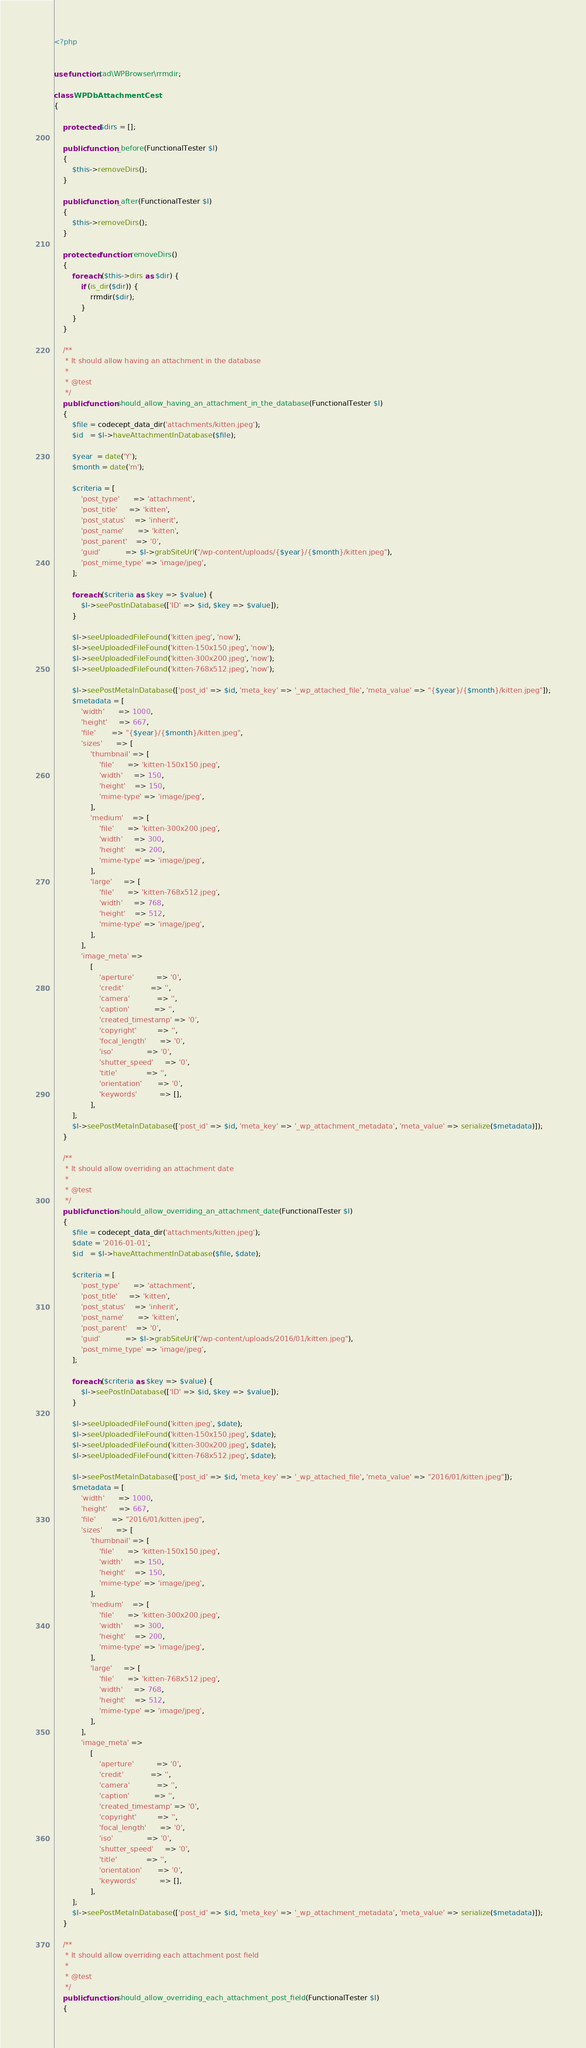Convert code to text. <code><loc_0><loc_0><loc_500><loc_500><_PHP_><?php


use function tad\WPBrowser\rrmdir;

class WPDbAttachmentCest
{

    protected $dirs = [];

    public function _before(FunctionalTester $I)
    {
        $this->removeDirs();
    }

    public function _after(FunctionalTester $I)
    {
        $this->removeDirs();
    }

    protected function removeDirs()
    {
        foreach ($this->dirs as $dir) {
            if (is_dir($dir)) {
                rrmdir($dir);
            }
        }
    }

    /**
     * It should allow having an attachment in the database
     *
     * @test
     */
    public function should_allow_having_an_attachment_in_the_database(FunctionalTester $I)
    {
        $file = codecept_data_dir('attachments/kitten.jpeg');
        $id   = $I->haveAttachmentInDatabase($file);

        $year  = date('Y');
        $month = date('m');

        $criteria = [
            'post_type'      => 'attachment',
            'post_title'     => 'kitten',
            'post_status'    => 'inherit',
            'post_name'      => 'kitten',
            'post_parent'    => '0',
            'guid'           => $I->grabSiteUrl("/wp-content/uploads/{$year}/{$month}/kitten.jpeg"),
            'post_mime_type' => 'image/jpeg',
        ];

        foreach ($criteria as $key => $value) {
            $I->seePostInDatabase(['ID' => $id, $key => $value]);
        }

        $I->seeUploadedFileFound('kitten.jpeg', 'now');
        $I->seeUploadedFileFound('kitten-150x150.jpeg', 'now');
        $I->seeUploadedFileFound('kitten-300x200.jpeg', 'now');
        $I->seeUploadedFileFound('kitten-768x512.jpeg', 'now');

        $I->seePostMetaInDatabase(['post_id' => $id, 'meta_key' => '_wp_attached_file', 'meta_value' => "{$year}/{$month}/kitten.jpeg"]);
        $metadata = [
            'width'      => 1000,
            'height'     => 667,
            'file'       => "{$year}/{$month}/kitten.jpeg",
            'sizes'      => [
                'thumbnail' => [
                    'file'      => 'kitten-150x150.jpeg',
                    'width'     => 150,
                    'height'    => 150,
                    'mime-type' => 'image/jpeg',
                ],
                'medium'    => [
                    'file'      => 'kitten-300x200.jpeg',
                    'width'     => 300,
                    'height'    => 200,
                    'mime-type' => 'image/jpeg',
                ],
                'large'     => [
                    'file'      => 'kitten-768x512.jpeg',
                    'width'     => 768,
                    'height'    => 512,
                    'mime-type' => 'image/jpeg',
                ],
            ],
            'image_meta' =>
                [
                    'aperture'          => '0',
                    'credit'            => '',
                    'camera'            => '',
                    'caption'           => '',
                    'created_timestamp' => '0',
                    'copyright'         => '',
                    'focal_length'      => '0',
                    'iso'               => '0',
                    'shutter_speed'     => '0',
                    'title'             => '',
                    'orientation'       => '0',
                    'keywords'          => [],
                ],
        ];
        $I->seePostMetaInDatabase(['post_id' => $id, 'meta_key' => '_wp_attachment_metadata', 'meta_value' => serialize($metadata)]);
    }

    /**
     * It should allow overriding an attachment date
     *
     * @test
     */
    public function should_allow_overriding_an_attachment_date(FunctionalTester $I)
    {
        $file = codecept_data_dir('attachments/kitten.jpeg');
        $date = '2016-01-01';
        $id   = $I->haveAttachmentInDatabase($file, $date);

        $criteria = [
            'post_type'      => 'attachment',
            'post_title'     => 'kitten',
            'post_status'    => 'inherit',
            'post_name'      => 'kitten',
            'post_parent'    => '0',
            'guid'           => $I->grabSiteUrl("/wp-content/uploads/2016/01/kitten.jpeg"),
            'post_mime_type' => 'image/jpeg',
        ];

        foreach ($criteria as $key => $value) {
            $I->seePostInDatabase(['ID' => $id, $key => $value]);
        }

        $I->seeUploadedFileFound('kitten.jpeg', $date);
        $I->seeUploadedFileFound('kitten-150x150.jpeg', $date);
        $I->seeUploadedFileFound('kitten-300x200.jpeg', $date);
        $I->seeUploadedFileFound('kitten-768x512.jpeg', $date);

        $I->seePostMetaInDatabase(['post_id' => $id, 'meta_key' => '_wp_attached_file', 'meta_value' => "2016/01/kitten.jpeg"]);
        $metadata = [
            'width'      => 1000,
            'height'     => 667,
            'file'       => "2016/01/kitten.jpeg",
            'sizes'      => [
                'thumbnail' => [
                    'file'      => 'kitten-150x150.jpeg',
                    'width'     => 150,
                    'height'    => 150,
                    'mime-type' => 'image/jpeg',
                ],
                'medium'    => [
                    'file'      => 'kitten-300x200.jpeg',
                    'width'     => 300,
                    'height'    => 200,
                    'mime-type' => 'image/jpeg',
                ],
                'large'     => [
                    'file'      => 'kitten-768x512.jpeg',
                    'width'     => 768,
                    'height'    => 512,
                    'mime-type' => 'image/jpeg',
                ],
            ],
            'image_meta' =>
                [
                    'aperture'          => '0',
                    'credit'            => '',
                    'camera'            => '',
                    'caption'           => '',
                    'created_timestamp' => '0',
                    'copyright'         => '',
                    'focal_length'      => '0',
                    'iso'               => '0',
                    'shutter_speed'     => '0',
                    'title'             => '',
                    'orientation'       => '0',
                    'keywords'          => [],
                ],
        ];
        $I->seePostMetaInDatabase(['post_id' => $id, 'meta_key' => '_wp_attachment_metadata', 'meta_value' => serialize($metadata)]);
    }

    /**
     * It should allow overriding each attachment post field
     *
     * @test
     */
    public function should_allow_overriding_each_attachment_post_field(FunctionalTester $I)
    {</code> 